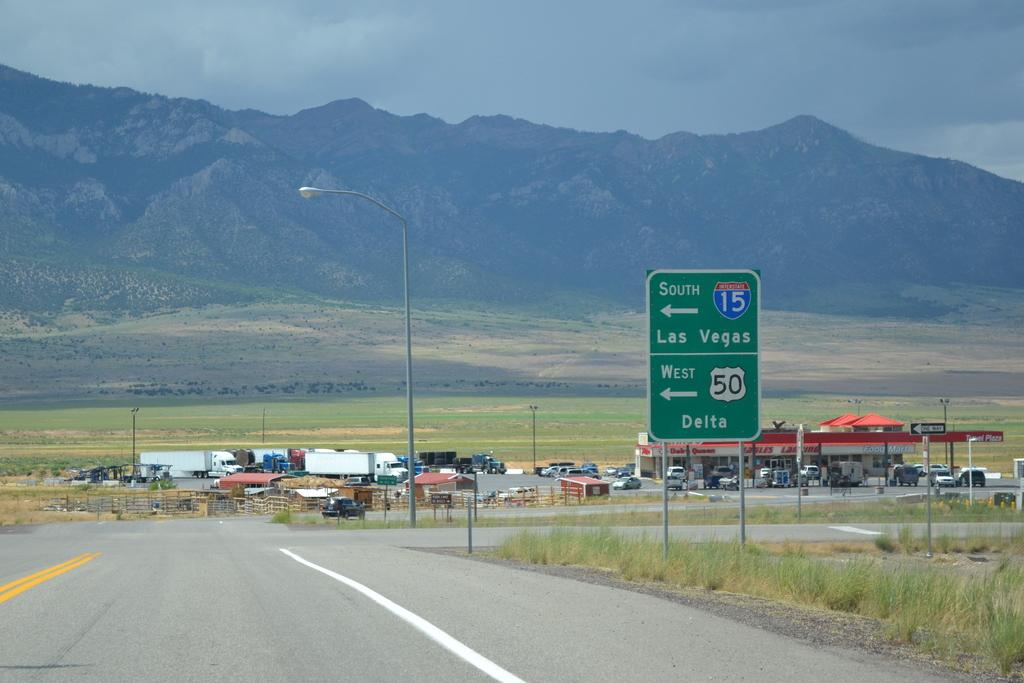<image>
Offer a succinct explanation of the picture presented. A road sign that reads SOUTH LAS VEGAS. 